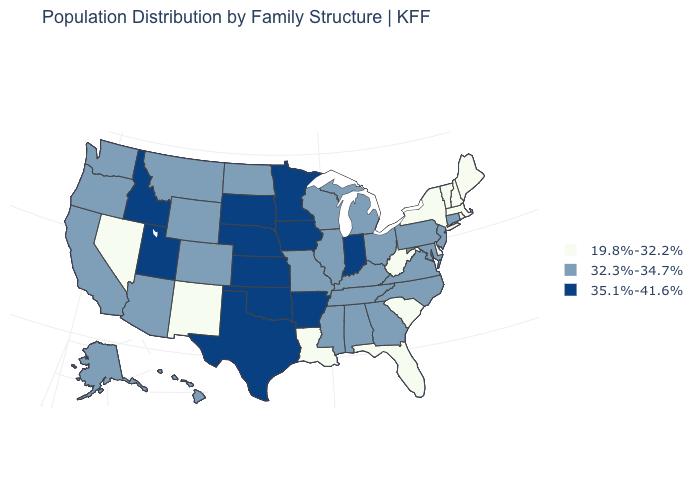Does New Mexico have a lower value than Delaware?
Concise answer only. No. What is the value of New Hampshire?
Give a very brief answer. 19.8%-32.2%. Name the states that have a value in the range 19.8%-32.2%?
Quick response, please. Delaware, Florida, Louisiana, Maine, Massachusetts, Nevada, New Hampshire, New Mexico, New York, Rhode Island, South Carolina, Vermont, West Virginia. Does New Mexico have the lowest value in the USA?
Be succinct. Yes. What is the value of Maryland?
Quick response, please. 32.3%-34.7%. Which states have the highest value in the USA?
Answer briefly. Arkansas, Idaho, Indiana, Iowa, Kansas, Minnesota, Nebraska, Oklahoma, South Dakota, Texas, Utah. Does the first symbol in the legend represent the smallest category?
Be succinct. Yes. Which states have the lowest value in the MidWest?
Give a very brief answer. Illinois, Michigan, Missouri, North Dakota, Ohio, Wisconsin. Name the states that have a value in the range 35.1%-41.6%?
Give a very brief answer. Arkansas, Idaho, Indiana, Iowa, Kansas, Minnesota, Nebraska, Oklahoma, South Dakota, Texas, Utah. What is the value of New York?
Keep it brief. 19.8%-32.2%. What is the value of South Dakota?
Keep it brief. 35.1%-41.6%. What is the lowest value in the MidWest?
Concise answer only. 32.3%-34.7%. How many symbols are there in the legend?
Short answer required. 3. Among the states that border Kansas , which have the highest value?
Give a very brief answer. Nebraska, Oklahoma. How many symbols are there in the legend?
Concise answer only. 3. 